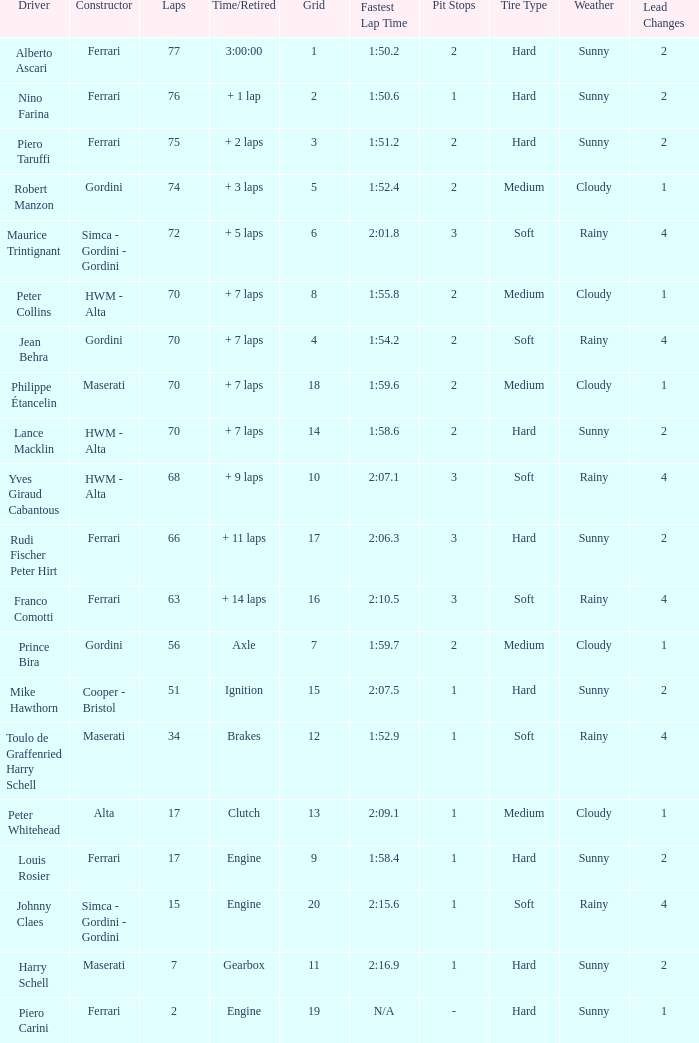What is the high grid for ferrari's with 2 laps? 19.0. 